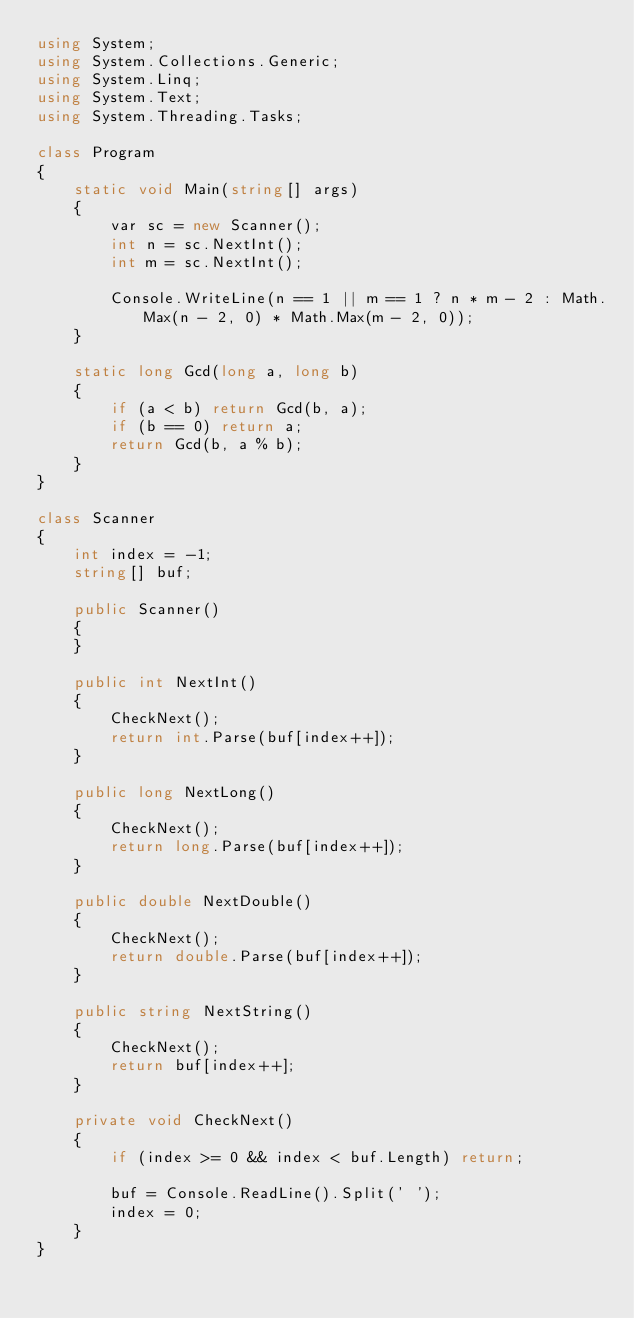<code> <loc_0><loc_0><loc_500><loc_500><_C#_>using System;
using System.Collections.Generic;
using System.Linq;
using System.Text;
using System.Threading.Tasks;

class Program
{
    static void Main(string[] args)
    {
        var sc = new Scanner();
        int n = sc.NextInt();
        int m = sc.NextInt();

        Console.WriteLine(n == 1 || m == 1 ? n * m - 2 : Math.Max(n - 2, 0) * Math.Max(m - 2, 0));
    }

    static long Gcd(long a, long b)
    {
        if (a < b) return Gcd(b, a);
        if (b == 0) return a;
        return Gcd(b, a % b);
    }
}

class Scanner
{
    int index = -1;
    string[] buf;

    public Scanner()
    {
    }

    public int NextInt()
    {
        CheckNext();
        return int.Parse(buf[index++]);
    }

    public long NextLong()
    {
        CheckNext();
        return long.Parse(buf[index++]);
    }

    public double NextDouble()
    {
        CheckNext();
        return double.Parse(buf[index++]);
    }

    public string NextString()
    {
        CheckNext();
        return buf[index++];
    }

    private void CheckNext()
    {
        if (index >= 0 && index < buf.Length) return;

        buf = Console.ReadLine().Split(' ');
        index = 0;
    }
}
</code> 